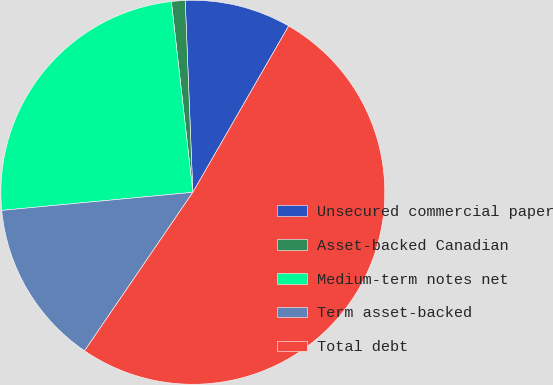Convert chart. <chart><loc_0><loc_0><loc_500><loc_500><pie_chart><fcel>Unsecured commercial paper<fcel>Asset-backed Canadian<fcel>Medium-term notes net<fcel>Term asset-backed<fcel>Total debt<nl><fcel>8.95%<fcel>1.15%<fcel>24.72%<fcel>13.96%<fcel>51.22%<nl></chart> 